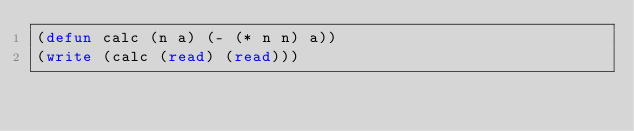<code> <loc_0><loc_0><loc_500><loc_500><_Lisp_>(defun calc (n a) (- (* n n) a))
(write (calc (read) (read)))</code> 